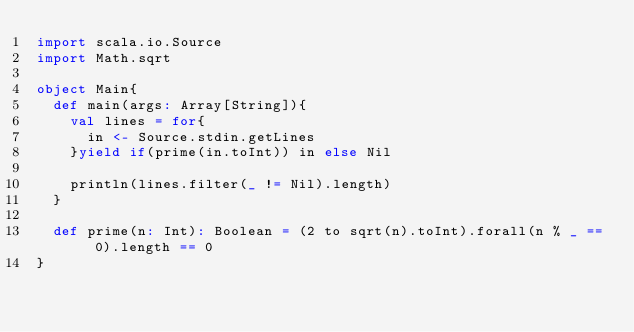<code> <loc_0><loc_0><loc_500><loc_500><_Scala_>import scala.io.Source
import Math.sqrt

object Main{
  def main(args: Array[String]){
    val lines = for{
      in <- Source.stdin.getLines
    }yield if(prime(in.toInt)) in else Nil

    println(lines.filter(_ != Nil).length)
  }

  def prime(n: Int): Boolean = (2 to sqrt(n).toInt).forall(n % _ == 0).length == 0
}</code> 